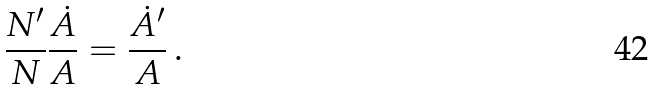Convert formula to latex. <formula><loc_0><loc_0><loc_500><loc_500>\frac { N ^ { \prime } } { N } \frac { \dot { A } } { A } = \frac { \dot { A } ^ { \prime } } { A } \, .</formula> 